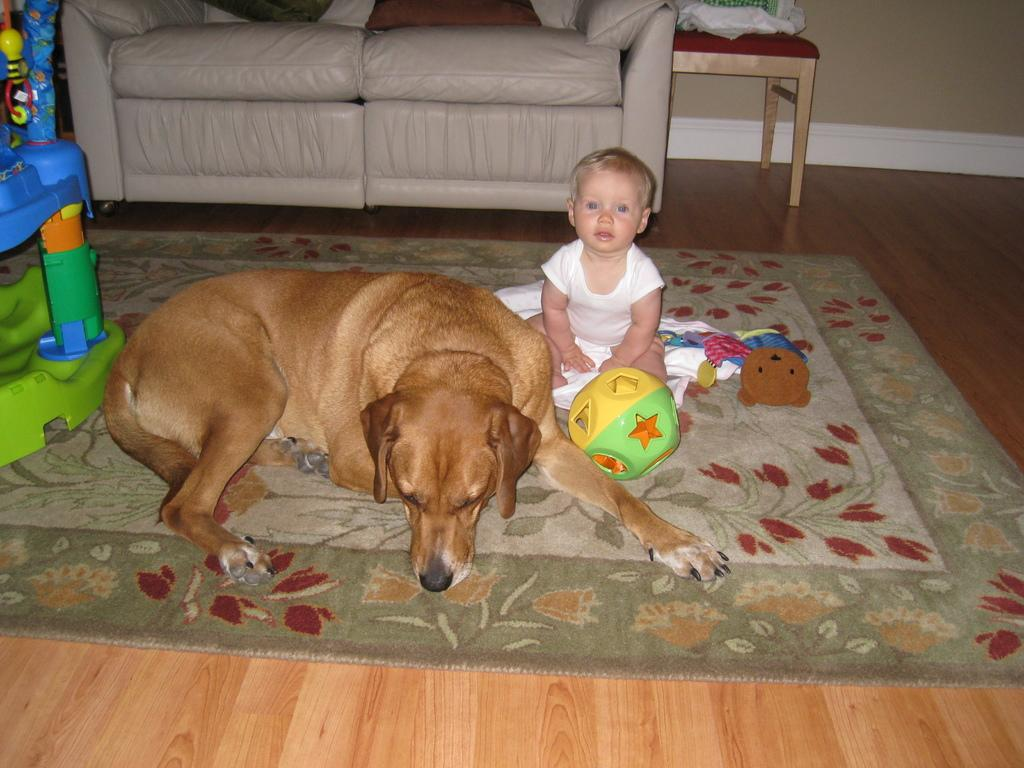What type of animal is in the image? There is a dog in the image. What object is also present in the image? There is a ball in the image. Who else is in the image? There is a baby in the image. Where are the dog, ball, and baby located? They are on a carpet in the image. What furniture can be seen in the image? There is a sofa and a chair in the image. What type of engine is visible in the image? There is no engine present in the image. How much blood can be seen on the carpet in the image? There is no blood visible in the image; it is a scene with a dog, ball, baby, carpet, sofa, and chair. 